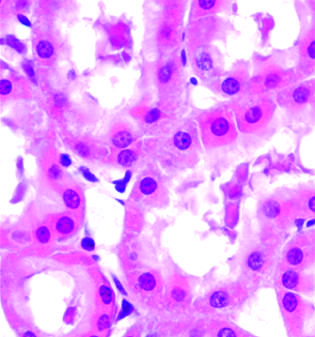did early (reversible) ischemic injury increase eosinophilia of cytoplasm, and swelling of occasional cells?
Answer the question using a single word or phrase. No 